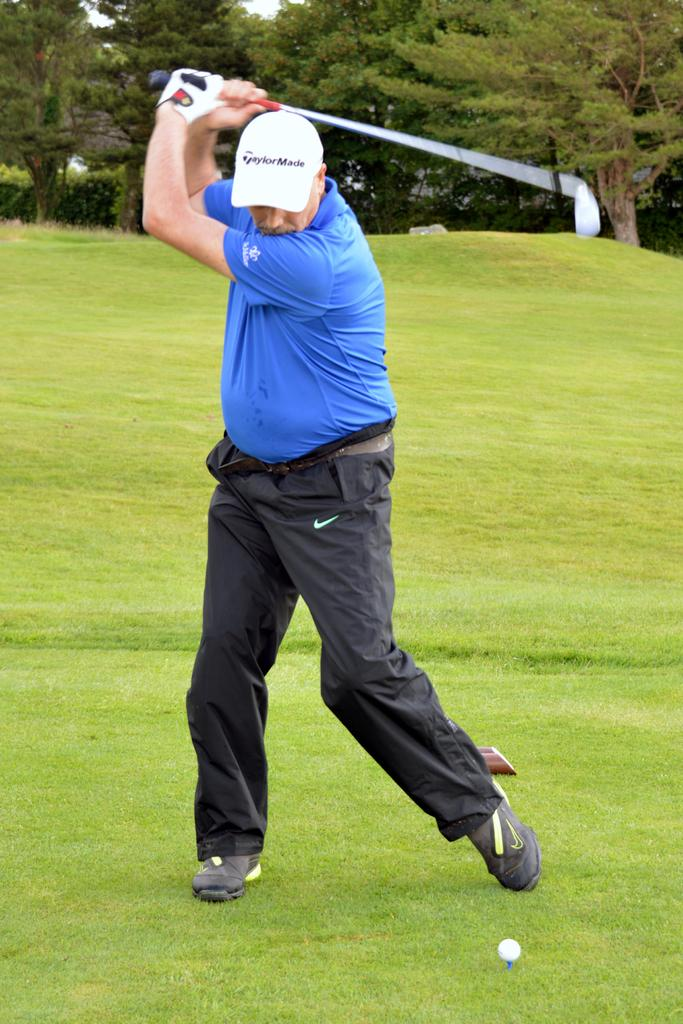What is the main subject of the image? The main subject of the image is a man standing. What is the man wearing in the image? The man is wearing clothes, a cap, shoes, and a glove in the image. What objects related to golf can be seen in the image? There is a golf stick and a golf ball in the image. What type of terrain is visible in the image? There is grass and trees visible in the image. Can you tell me where the mother is standing in the image? There is no mother present in the image; the main subject is a man standing. Is there a fan visible in the image? There is no fan present in the image. 